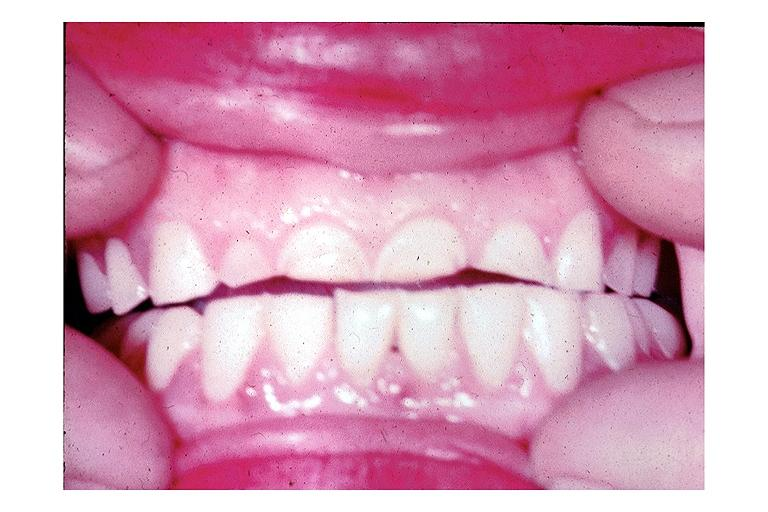does this image show attrition?
Answer the question using a single word or phrase. Yes 